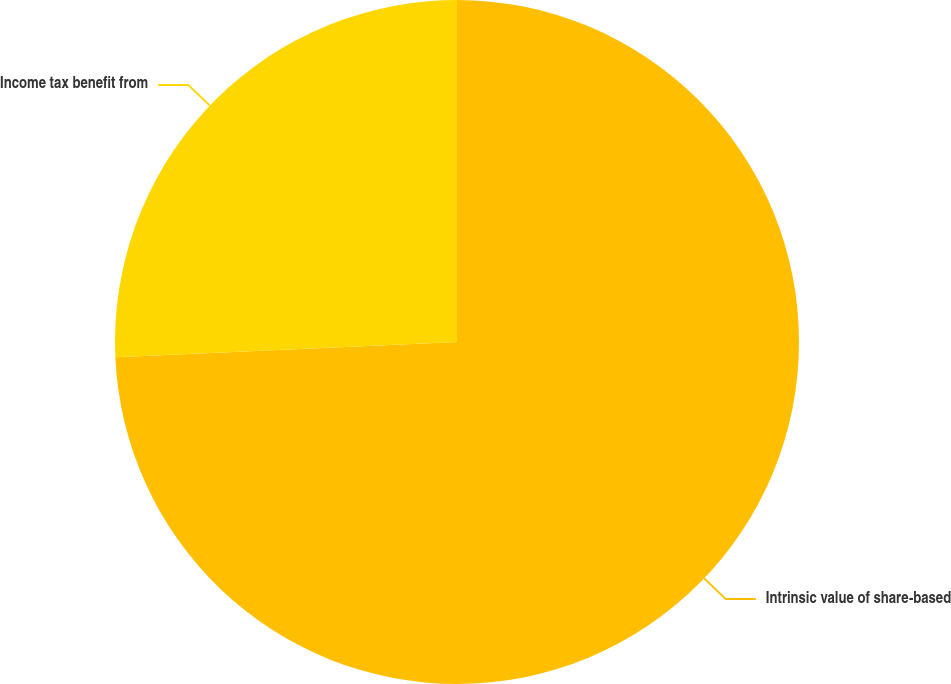Convert chart to OTSL. <chart><loc_0><loc_0><loc_500><loc_500><pie_chart><fcel>Intrinsic value of share-based<fcel>Income tax benefit from<nl><fcel>74.29%<fcel>25.71%<nl></chart> 